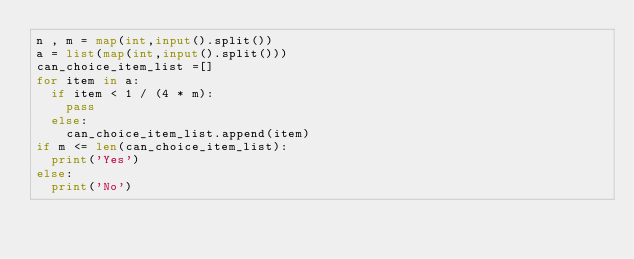<code> <loc_0><loc_0><loc_500><loc_500><_Python_>n , m = map(int,input().split())
a = list(map(int,input().split()))
can_choice_item_list =[]
for item in a:
  if item < 1 / (4 * m):
    pass
  else:
    can_choice_item_list.append(item)
if m <= len(can_choice_item_list):
  print('Yes')
else:
  print('No')</code> 